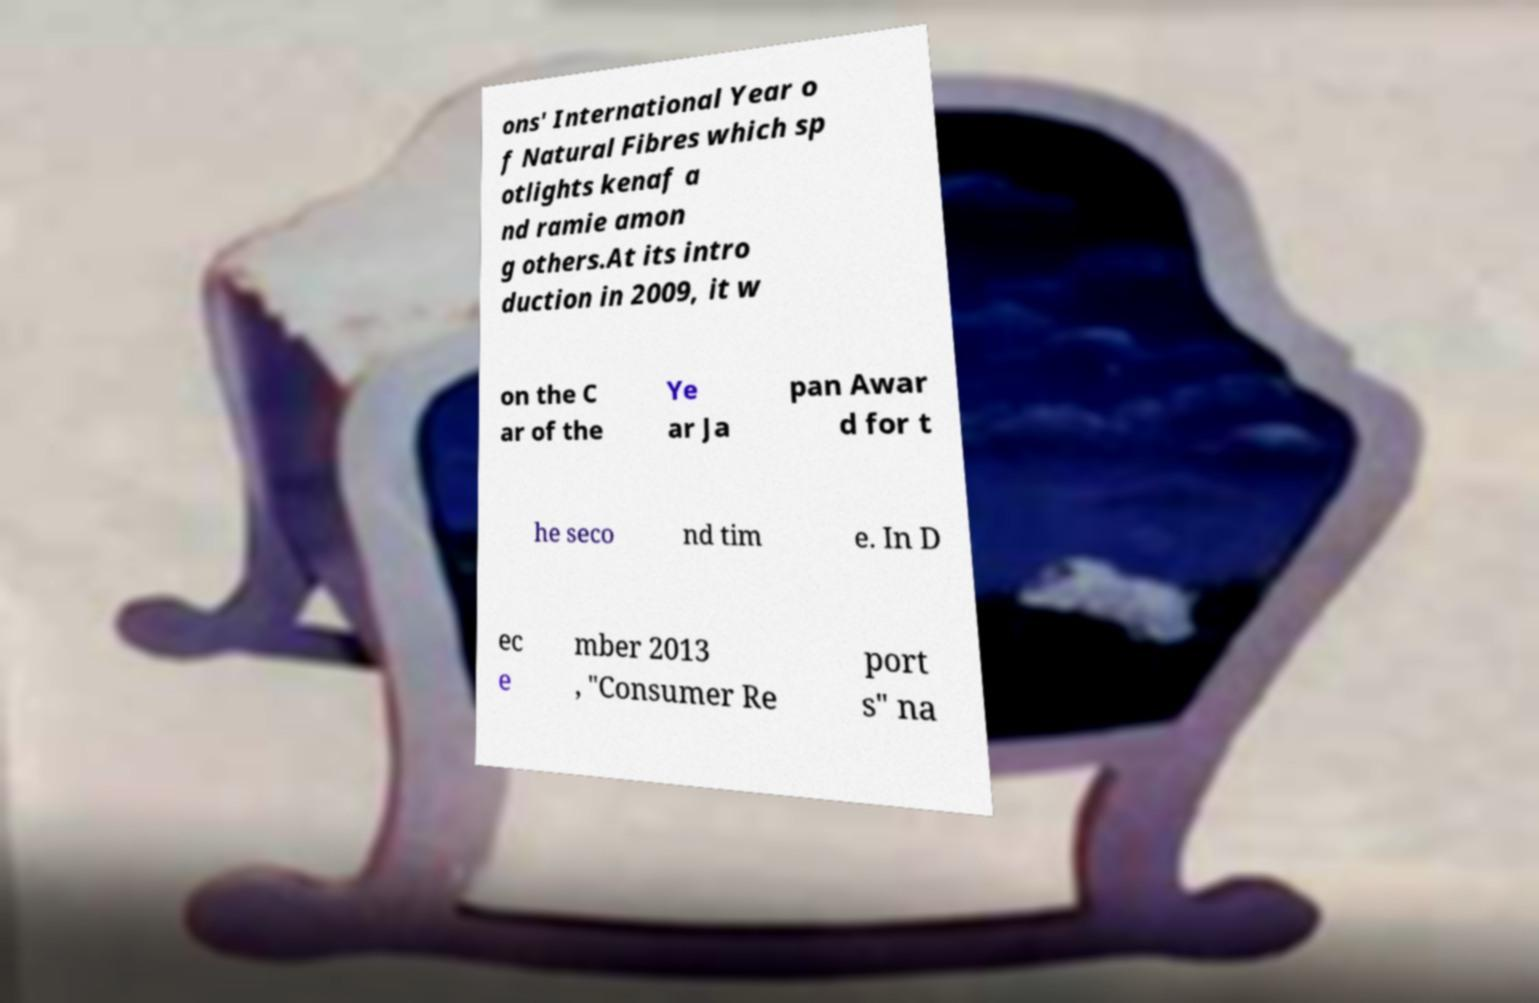Please read and relay the text visible in this image. What does it say? ons' International Year o f Natural Fibres which sp otlights kenaf a nd ramie amon g others.At its intro duction in 2009, it w on the C ar of the Ye ar Ja pan Awar d for t he seco nd tim e. In D ec e mber 2013 , "Consumer Re port s" na 